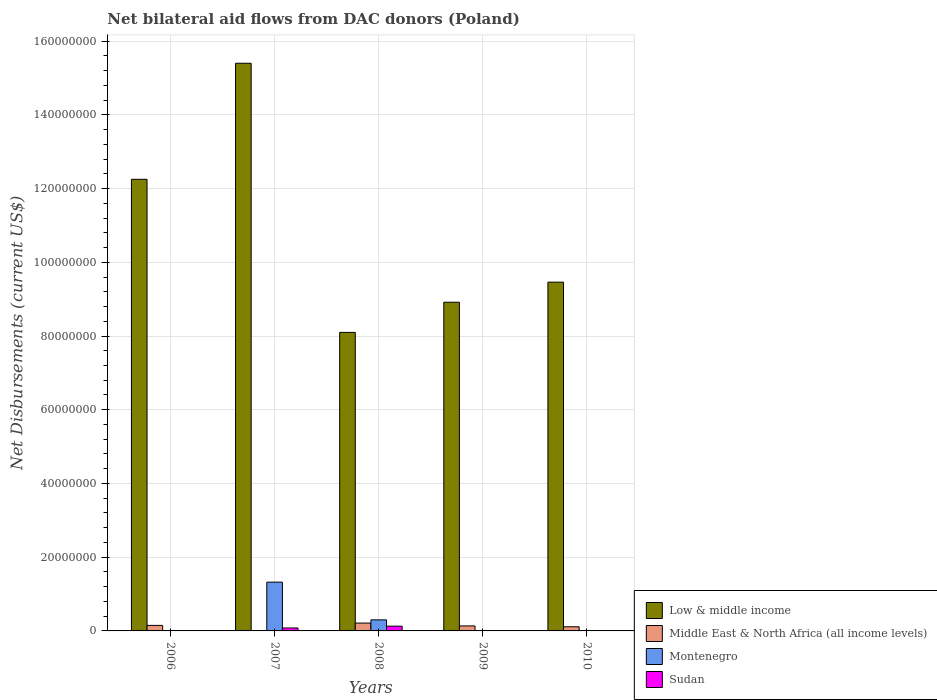Are the number of bars on each tick of the X-axis equal?
Your answer should be compact. No. How many bars are there on the 5th tick from the left?
Your answer should be compact. 3. How many bars are there on the 3rd tick from the right?
Your answer should be very brief. 4. What is the net bilateral aid flows in Low & middle income in 2008?
Offer a terse response. 8.10e+07. Across all years, what is the maximum net bilateral aid flows in Low & middle income?
Offer a terse response. 1.54e+08. Across all years, what is the minimum net bilateral aid flows in Low & middle income?
Make the answer very short. 8.10e+07. In which year was the net bilateral aid flows in Middle East & North Africa (all income levels) maximum?
Your response must be concise. 2008. What is the total net bilateral aid flows in Sudan in the graph?
Offer a terse response. 2.22e+06. What is the difference between the net bilateral aid flows in Sudan in 2007 and that in 2009?
Keep it short and to the point. 7.90e+05. What is the difference between the net bilateral aid flows in Low & middle income in 2009 and the net bilateral aid flows in Montenegro in 2006?
Offer a terse response. 8.91e+07. What is the average net bilateral aid flows in Middle East & North Africa (all income levels) per year?
Your answer should be compact. 1.22e+06. In the year 2010, what is the difference between the net bilateral aid flows in Sudan and net bilateral aid flows in Low & middle income?
Your response must be concise. -9.46e+07. What is the ratio of the net bilateral aid flows in Montenegro in 2006 to that in 2009?
Your answer should be compact. 2.25. Is the difference between the net bilateral aid flows in Sudan in 2007 and 2008 greater than the difference between the net bilateral aid flows in Low & middle income in 2007 and 2008?
Your answer should be compact. No. What is the difference between the highest and the lowest net bilateral aid flows in Sudan?
Your answer should be very brief. 1.28e+06. In how many years, is the net bilateral aid flows in Sudan greater than the average net bilateral aid flows in Sudan taken over all years?
Offer a terse response. 2. Is the sum of the net bilateral aid flows in Low & middle income in 2008 and 2009 greater than the maximum net bilateral aid flows in Middle East & North Africa (all income levels) across all years?
Keep it short and to the point. Yes. How many bars are there?
Offer a very short reply. 18. Are all the bars in the graph horizontal?
Provide a succinct answer. No. How many years are there in the graph?
Your response must be concise. 5. Are the values on the major ticks of Y-axis written in scientific E-notation?
Provide a short and direct response. No. Does the graph contain grids?
Offer a very short reply. Yes. Where does the legend appear in the graph?
Your answer should be compact. Bottom right. How many legend labels are there?
Your response must be concise. 4. What is the title of the graph?
Make the answer very short. Net bilateral aid flows from DAC donors (Poland). What is the label or title of the X-axis?
Give a very brief answer. Years. What is the label or title of the Y-axis?
Make the answer very short. Net Disbursements (current US$). What is the Net Disbursements (current US$) in Low & middle income in 2006?
Your answer should be very brief. 1.23e+08. What is the Net Disbursements (current US$) of Middle East & North Africa (all income levels) in 2006?
Provide a succinct answer. 1.50e+06. What is the Net Disbursements (current US$) in Low & middle income in 2007?
Keep it short and to the point. 1.54e+08. What is the Net Disbursements (current US$) in Montenegro in 2007?
Your response must be concise. 1.32e+07. What is the Net Disbursements (current US$) of Sudan in 2007?
Your answer should be compact. 8.00e+05. What is the Net Disbursements (current US$) of Low & middle income in 2008?
Your answer should be very brief. 8.10e+07. What is the Net Disbursements (current US$) of Middle East & North Africa (all income levels) in 2008?
Keep it short and to the point. 2.13e+06. What is the Net Disbursements (current US$) in Sudan in 2008?
Your answer should be compact. 1.29e+06. What is the Net Disbursements (current US$) in Low & middle income in 2009?
Provide a short and direct response. 8.92e+07. What is the Net Disbursements (current US$) of Middle East & North Africa (all income levels) in 2009?
Your answer should be compact. 1.36e+06. What is the Net Disbursements (current US$) of Sudan in 2009?
Your answer should be very brief. 10000. What is the Net Disbursements (current US$) of Low & middle income in 2010?
Offer a terse response. 9.46e+07. What is the Net Disbursements (current US$) of Middle East & North Africa (all income levels) in 2010?
Provide a short and direct response. 1.13e+06. What is the Net Disbursements (current US$) of Montenegro in 2010?
Offer a very short reply. 0. What is the Net Disbursements (current US$) of Sudan in 2010?
Keep it short and to the point. 6.00e+04. Across all years, what is the maximum Net Disbursements (current US$) of Low & middle income?
Your answer should be very brief. 1.54e+08. Across all years, what is the maximum Net Disbursements (current US$) in Middle East & North Africa (all income levels)?
Make the answer very short. 2.13e+06. Across all years, what is the maximum Net Disbursements (current US$) of Montenegro?
Offer a very short reply. 1.32e+07. Across all years, what is the maximum Net Disbursements (current US$) in Sudan?
Keep it short and to the point. 1.29e+06. Across all years, what is the minimum Net Disbursements (current US$) in Low & middle income?
Offer a very short reply. 8.10e+07. What is the total Net Disbursements (current US$) of Low & middle income in the graph?
Your answer should be compact. 5.41e+08. What is the total Net Disbursements (current US$) in Middle East & North Africa (all income levels) in the graph?
Your answer should be compact. 6.12e+06. What is the total Net Disbursements (current US$) in Montenegro in the graph?
Provide a succinct answer. 1.64e+07. What is the total Net Disbursements (current US$) in Sudan in the graph?
Provide a succinct answer. 2.22e+06. What is the difference between the Net Disbursements (current US$) in Low & middle income in 2006 and that in 2007?
Your response must be concise. -3.15e+07. What is the difference between the Net Disbursements (current US$) of Montenegro in 2006 and that in 2007?
Your answer should be very brief. -1.31e+07. What is the difference between the Net Disbursements (current US$) in Sudan in 2006 and that in 2007?
Your response must be concise. -7.40e+05. What is the difference between the Net Disbursements (current US$) in Low & middle income in 2006 and that in 2008?
Provide a short and direct response. 4.15e+07. What is the difference between the Net Disbursements (current US$) of Middle East & North Africa (all income levels) in 2006 and that in 2008?
Your answer should be very brief. -6.30e+05. What is the difference between the Net Disbursements (current US$) of Montenegro in 2006 and that in 2008?
Provide a succinct answer. -2.91e+06. What is the difference between the Net Disbursements (current US$) in Sudan in 2006 and that in 2008?
Make the answer very short. -1.23e+06. What is the difference between the Net Disbursements (current US$) in Low & middle income in 2006 and that in 2009?
Ensure brevity in your answer.  3.34e+07. What is the difference between the Net Disbursements (current US$) in Montenegro in 2006 and that in 2009?
Offer a very short reply. 5.00e+04. What is the difference between the Net Disbursements (current US$) in Low & middle income in 2006 and that in 2010?
Give a very brief answer. 2.79e+07. What is the difference between the Net Disbursements (current US$) in Middle East & North Africa (all income levels) in 2006 and that in 2010?
Make the answer very short. 3.70e+05. What is the difference between the Net Disbursements (current US$) in Low & middle income in 2007 and that in 2008?
Offer a very short reply. 7.30e+07. What is the difference between the Net Disbursements (current US$) of Montenegro in 2007 and that in 2008?
Give a very brief answer. 1.02e+07. What is the difference between the Net Disbursements (current US$) in Sudan in 2007 and that in 2008?
Ensure brevity in your answer.  -4.90e+05. What is the difference between the Net Disbursements (current US$) of Low & middle income in 2007 and that in 2009?
Your answer should be compact. 6.48e+07. What is the difference between the Net Disbursements (current US$) of Montenegro in 2007 and that in 2009?
Keep it short and to the point. 1.32e+07. What is the difference between the Net Disbursements (current US$) of Sudan in 2007 and that in 2009?
Keep it short and to the point. 7.90e+05. What is the difference between the Net Disbursements (current US$) of Low & middle income in 2007 and that in 2010?
Ensure brevity in your answer.  5.94e+07. What is the difference between the Net Disbursements (current US$) in Sudan in 2007 and that in 2010?
Give a very brief answer. 7.40e+05. What is the difference between the Net Disbursements (current US$) in Low & middle income in 2008 and that in 2009?
Ensure brevity in your answer.  -8.18e+06. What is the difference between the Net Disbursements (current US$) of Middle East & North Africa (all income levels) in 2008 and that in 2009?
Offer a terse response. 7.70e+05. What is the difference between the Net Disbursements (current US$) of Montenegro in 2008 and that in 2009?
Provide a short and direct response. 2.96e+06. What is the difference between the Net Disbursements (current US$) of Sudan in 2008 and that in 2009?
Your answer should be compact. 1.28e+06. What is the difference between the Net Disbursements (current US$) in Low & middle income in 2008 and that in 2010?
Your answer should be compact. -1.36e+07. What is the difference between the Net Disbursements (current US$) in Sudan in 2008 and that in 2010?
Offer a very short reply. 1.23e+06. What is the difference between the Net Disbursements (current US$) of Low & middle income in 2009 and that in 2010?
Make the answer very short. -5.45e+06. What is the difference between the Net Disbursements (current US$) in Middle East & North Africa (all income levels) in 2009 and that in 2010?
Keep it short and to the point. 2.30e+05. What is the difference between the Net Disbursements (current US$) of Low & middle income in 2006 and the Net Disbursements (current US$) of Montenegro in 2007?
Your response must be concise. 1.09e+08. What is the difference between the Net Disbursements (current US$) of Low & middle income in 2006 and the Net Disbursements (current US$) of Sudan in 2007?
Provide a short and direct response. 1.22e+08. What is the difference between the Net Disbursements (current US$) in Middle East & North Africa (all income levels) in 2006 and the Net Disbursements (current US$) in Montenegro in 2007?
Make the answer very short. -1.17e+07. What is the difference between the Net Disbursements (current US$) in Montenegro in 2006 and the Net Disbursements (current US$) in Sudan in 2007?
Provide a succinct answer. -7.10e+05. What is the difference between the Net Disbursements (current US$) of Low & middle income in 2006 and the Net Disbursements (current US$) of Middle East & North Africa (all income levels) in 2008?
Keep it short and to the point. 1.20e+08. What is the difference between the Net Disbursements (current US$) of Low & middle income in 2006 and the Net Disbursements (current US$) of Montenegro in 2008?
Give a very brief answer. 1.20e+08. What is the difference between the Net Disbursements (current US$) of Low & middle income in 2006 and the Net Disbursements (current US$) of Sudan in 2008?
Provide a succinct answer. 1.21e+08. What is the difference between the Net Disbursements (current US$) in Middle East & North Africa (all income levels) in 2006 and the Net Disbursements (current US$) in Montenegro in 2008?
Your answer should be very brief. -1.50e+06. What is the difference between the Net Disbursements (current US$) in Montenegro in 2006 and the Net Disbursements (current US$) in Sudan in 2008?
Keep it short and to the point. -1.20e+06. What is the difference between the Net Disbursements (current US$) in Low & middle income in 2006 and the Net Disbursements (current US$) in Middle East & North Africa (all income levels) in 2009?
Offer a very short reply. 1.21e+08. What is the difference between the Net Disbursements (current US$) of Low & middle income in 2006 and the Net Disbursements (current US$) of Montenegro in 2009?
Make the answer very short. 1.22e+08. What is the difference between the Net Disbursements (current US$) in Low & middle income in 2006 and the Net Disbursements (current US$) in Sudan in 2009?
Give a very brief answer. 1.22e+08. What is the difference between the Net Disbursements (current US$) in Middle East & North Africa (all income levels) in 2006 and the Net Disbursements (current US$) in Montenegro in 2009?
Your answer should be compact. 1.46e+06. What is the difference between the Net Disbursements (current US$) in Middle East & North Africa (all income levels) in 2006 and the Net Disbursements (current US$) in Sudan in 2009?
Give a very brief answer. 1.49e+06. What is the difference between the Net Disbursements (current US$) in Low & middle income in 2006 and the Net Disbursements (current US$) in Middle East & North Africa (all income levels) in 2010?
Make the answer very short. 1.21e+08. What is the difference between the Net Disbursements (current US$) in Low & middle income in 2006 and the Net Disbursements (current US$) in Sudan in 2010?
Provide a short and direct response. 1.22e+08. What is the difference between the Net Disbursements (current US$) of Middle East & North Africa (all income levels) in 2006 and the Net Disbursements (current US$) of Sudan in 2010?
Your answer should be very brief. 1.44e+06. What is the difference between the Net Disbursements (current US$) of Low & middle income in 2007 and the Net Disbursements (current US$) of Middle East & North Africa (all income levels) in 2008?
Offer a very short reply. 1.52e+08. What is the difference between the Net Disbursements (current US$) of Low & middle income in 2007 and the Net Disbursements (current US$) of Montenegro in 2008?
Your answer should be very brief. 1.51e+08. What is the difference between the Net Disbursements (current US$) in Low & middle income in 2007 and the Net Disbursements (current US$) in Sudan in 2008?
Offer a very short reply. 1.53e+08. What is the difference between the Net Disbursements (current US$) in Montenegro in 2007 and the Net Disbursements (current US$) in Sudan in 2008?
Your response must be concise. 1.19e+07. What is the difference between the Net Disbursements (current US$) in Low & middle income in 2007 and the Net Disbursements (current US$) in Middle East & North Africa (all income levels) in 2009?
Provide a short and direct response. 1.53e+08. What is the difference between the Net Disbursements (current US$) of Low & middle income in 2007 and the Net Disbursements (current US$) of Montenegro in 2009?
Provide a succinct answer. 1.54e+08. What is the difference between the Net Disbursements (current US$) in Low & middle income in 2007 and the Net Disbursements (current US$) in Sudan in 2009?
Ensure brevity in your answer.  1.54e+08. What is the difference between the Net Disbursements (current US$) of Montenegro in 2007 and the Net Disbursements (current US$) of Sudan in 2009?
Ensure brevity in your answer.  1.32e+07. What is the difference between the Net Disbursements (current US$) in Low & middle income in 2007 and the Net Disbursements (current US$) in Middle East & North Africa (all income levels) in 2010?
Offer a terse response. 1.53e+08. What is the difference between the Net Disbursements (current US$) of Low & middle income in 2007 and the Net Disbursements (current US$) of Sudan in 2010?
Give a very brief answer. 1.54e+08. What is the difference between the Net Disbursements (current US$) in Montenegro in 2007 and the Net Disbursements (current US$) in Sudan in 2010?
Keep it short and to the point. 1.32e+07. What is the difference between the Net Disbursements (current US$) of Low & middle income in 2008 and the Net Disbursements (current US$) of Middle East & North Africa (all income levels) in 2009?
Ensure brevity in your answer.  7.96e+07. What is the difference between the Net Disbursements (current US$) in Low & middle income in 2008 and the Net Disbursements (current US$) in Montenegro in 2009?
Provide a succinct answer. 8.09e+07. What is the difference between the Net Disbursements (current US$) of Low & middle income in 2008 and the Net Disbursements (current US$) of Sudan in 2009?
Keep it short and to the point. 8.10e+07. What is the difference between the Net Disbursements (current US$) of Middle East & North Africa (all income levels) in 2008 and the Net Disbursements (current US$) of Montenegro in 2009?
Provide a succinct answer. 2.09e+06. What is the difference between the Net Disbursements (current US$) in Middle East & North Africa (all income levels) in 2008 and the Net Disbursements (current US$) in Sudan in 2009?
Offer a very short reply. 2.12e+06. What is the difference between the Net Disbursements (current US$) in Montenegro in 2008 and the Net Disbursements (current US$) in Sudan in 2009?
Keep it short and to the point. 2.99e+06. What is the difference between the Net Disbursements (current US$) in Low & middle income in 2008 and the Net Disbursements (current US$) in Middle East & North Africa (all income levels) in 2010?
Your answer should be compact. 7.98e+07. What is the difference between the Net Disbursements (current US$) of Low & middle income in 2008 and the Net Disbursements (current US$) of Sudan in 2010?
Offer a terse response. 8.09e+07. What is the difference between the Net Disbursements (current US$) of Middle East & North Africa (all income levels) in 2008 and the Net Disbursements (current US$) of Sudan in 2010?
Keep it short and to the point. 2.07e+06. What is the difference between the Net Disbursements (current US$) of Montenegro in 2008 and the Net Disbursements (current US$) of Sudan in 2010?
Your response must be concise. 2.94e+06. What is the difference between the Net Disbursements (current US$) of Low & middle income in 2009 and the Net Disbursements (current US$) of Middle East & North Africa (all income levels) in 2010?
Your answer should be very brief. 8.80e+07. What is the difference between the Net Disbursements (current US$) of Low & middle income in 2009 and the Net Disbursements (current US$) of Sudan in 2010?
Your response must be concise. 8.91e+07. What is the difference between the Net Disbursements (current US$) of Middle East & North Africa (all income levels) in 2009 and the Net Disbursements (current US$) of Sudan in 2010?
Your answer should be compact. 1.30e+06. What is the average Net Disbursements (current US$) in Low & middle income per year?
Offer a terse response. 1.08e+08. What is the average Net Disbursements (current US$) of Middle East & North Africa (all income levels) per year?
Give a very brief answer. 1.22e+06. What is the average Net Disbursements (current US$) of Montenegro per year?
Offer a terse response. 3.27e+06. What is the average Net Disbursements (current US$) in Sudan per year?
Your answer should be very brief. 4.44e+05. In the year 2006, what is the difference between the Net Disbursements (current US$) of Low & middle income and Net Disbursements (current US$) of Middle East & North Africa (all income levels)?
Offer a very short reply. 1.21e+08. In the year 2006, what is the difference between the Net Disbursements (current US$) of Low & middle income and Net Disbursements (current US$) of Montenegro?
Your response must be concise. 1.22e+08. In the year 2006, what is the difference between the Net Disbursements (current US$) in Low & middle income and Net Disbursements (current US$) in Sudan?
Give a very brief answer. 1.22e+08. In the year 2006, what is the difference between the Net Disbursements (current US$) in Middle East & North Africa (all income levels) and Net Disbursements (current US$) in Montenegro?
Ensure brevity in your answer.  1.41e+06. In the year 2006, what is the difference between the Net Disbursements (current US$) in Middle East & North Africa (all income levels) and Net Disbursements (current US$) in Sudan?
Give a very brief answer. 1.44e+06. In the year 2007, what is the difference between the Net Disbursements (current US$) of Low & middle income and Net Disbursements (current US$) of Montenegro?
Provide a succinct answer. 1.41e+08. In the year 2007, what is the difference between the Net Disbursements (current US$) of Low & middle income and Net Disbursements (current US$) of Sudan?
Your answer should be compact. 1.53e+08. In the year 2007, what is the difference between the Net Disbursements (current US$) of Montenegro and Net Disbursements (current US$) of Sudan?
Ensure brevity in your answer.  1.24e+07. In the year 2008, what is the difference between the Net Disbursements (current US$) in Low & middle income and Net Disbursements (current US$) in Middle East & North Africa (all income levels)?
Offer a very short reply. 7.88e+07. In the year 2008, what is the difference between the Net Disbursements (current US$) of Low & middle income and Net Disbursements (current US$) of Montenegro?
Provide a short and direct response. 7.80e+07. In the year 2008, what is the difference between the Net Disbursements (current US$) in Low & middle income and Net Disbursements (current US$) in Sudan?
Make the answer very short. 7.97e+07. In the year 2008, what is the difference between the Net Disbursements (current US$) of Middle East & North Africa (all income levels) and Net Disbursements (current US$) of Montenegro?
Give a very brief answer. -8.70e+05. In the year 2008, what is the difference between the Net Disbursements (current US$) in Middle East & North Africa (all income levels) and Net Disbursements (current US$) in Sudan?
Provide a succinct answer. 8.40e+05. In the year 2008, what is the difference between the Net Disbursements (current US$) of Montenegro and Net Disbursements (current US$) of Sudan?
Keep it short and to the point. 1.71e+06. In the year 2009, what is the difference between the Net Disbursements (current US$) of Low & middle income and Net Disbursements (current US$) of Middle East & North Africa (all income levels)?
Your answer should be very brief. 8.78e+07. In the year 2009, what is the difference between the Net Disbursements (current US$) in Low & middle income and Net Disbursements (current US$) in Montenegro?
Offer a very short reply. 8.91e+07. In the year 2009, what is the difference between the Net Disbursements (current US$) in Low & middle income and Net Disbursements (current US$) in Sudan?
Make the answer very short. 8.92e+07. In the year 2009, what is the difference between the Net Disbursements (current US$) of Middle East & North Africa (all income levels) and Net Disbursements (current US$) of Montenegro?
Your answer should be compact. 1.32e+06. In the year 2009, what is the difference between the Net Disbursements (current US$) in Middle East & North Africa (all income levels) and Net Disbursements (current US$) in Sudan?
Give a very brief answer. 1.35e+06. In the year 2010, what is the difference between the Net Disbursements (current US$) in Low & middle income and Net Disbursements (current US$) in Middle East & North Africa (all income levels)?
Give a very brief answer. 9.35e+07. In the year 2010, what is the difference between the Net Disbursements (current US$) of Low & middle income and Net Disbursements (current US$) of Sudan?
Keep it short and to the point. 9.46e+07. In the year 2010, what is the difference between the Net Disbursements (current US$) of Middle East & North Africa (all income levels) and Net Disbursements (current US$) of Sudan?
Make the answer very short. 1.07e+06. What is the ratio of the Net Disbursements (current US$) in Low & middle income in 2006 to that in 2007?
Ensure brevity in your answer.  0.8. What is the ratio of the Net Disbursements (current US$) of Montenegro in 2006 to that in 2007?
Keep it short and to the point. 0.01. What is the ratio of the Net Disbursements (current US$) of Sudan in 2006 to that in 2007?
Your answer should be very brief. 0.07. What is the ratio of the Net Disbursements (current US$) in Low & middle income in 2006 to that in 2008?
Make the answer very short. 1.51. What is the ratio of the Net Disbursements (current US$) in Middle East & North Africa (all income levels) in 2006 to that in 2008?
Provide a succinct answer. 0.7. What is the ratio of the Net Disbursements (current US$) of Sudan in 2006 to that in 2008?
Keep it short and to the point. 0.05. What is the ratio of the Net Disbursements (current US$) in Low & middle income in 2006 to that in 2009?
Your answer should be compact. 1.37. What is the ratio of the Net Disbursements (current US$) of Middle East & North Africa (all income levels) in 2006 to that in 2009?
Your response must be concise. 1.1. What is the ratio of the Net Disbursements (current US$) of Montenegro in 2006 to that in 2009?
Your answer should be compact. 2.25. What is the ratio of the Net Disbursements (current US$) in Sudan in 2006 to that in 2009?
Your response must be concise. 6. What is the ratio of the Net Disbursements (current US$) of Low & middle income in 2006 to that in 2010?
Your answer should be compact. 1.29. What is the ratio of the Net Disbursements (current US$) in Middle East & North Africa (all income levels) in 2006 to that in 2010?
Provide a short and direct response. 1.33. What is the ratio of the Net Disbursements (current US$) in Sudan in 2006 to that in 2010?
Your answer should be compact. 1. What is the ratio of the Net Disbursements (current US$) in Low & middle income in 2007 to that in 2008?
Offer a very short reply. 1.9. What is the ratio of the Net Disbursements (current US$) in Montenegro in 2007 to that in 2008?
Provide a short and direct response. 4.41. What is the ratio of the Net Disbursements (current US$) of Sudan in 2007 to that in 2008?
Your response must be concise. 0.62. What is the ratio of the Net Disbursements (current US$) in Low & middle income in 2007 to that in 2009?
Offer a very short reply. 1.73. What is the ratio of the Net Disbursements (current US$) of Montenegro in 2007 to that in 2009?
Keep it short and to the point. 330.75. What is the ratio of the Net Disbursements (current US$) in Low & middle income in 2007 to that in 2010?
Keep it short and to the point. 1.63. What is the ratio of the Net Disbursements (current US$) of Sudan in 2007 to that in 2010?
Keep it short and to the point. 13.33. What is the ratio of the Net Disbursements (current US$) of Low & middle income in 2008 to that in 2009?
Your answer should be compact. 0.91. What is the ratio of the Net Disbursements (current US$) in Middle East & North Africa (all income levels) in 2008 to that in 2009?
Offer a very short reply. 1.57. What is the ratio of the Net Disbursements (current US$) of Montenegro in 2008 to that in 2009?
Keep it short and to the point. 75. What is the ratio of the Net Disbursements (current US$) of Sudan in 2008 to that in 2009?
Make the answer very short. 129. What is the ratio of the Net Disbursements (current US$) of Low & middle income in 2008 to that in 2010?
Your response must be concise. 0.86. What is the ratio of the Net Disbursements (current US$) in Middle East & North Africa (all income levels) in 2008 to that in 2010?
Give a very brief answer. 1.89. What is the ratio of the Net Disbursements (current US$) of Low & middle income in 2009 to that in 2010?
Keep it short and to the point. 0.94. What is the ratio of the Net Disbursements (current US$) in Middle East & North Africa (all income levels) in 2009 to that in 2010?
Ensure brevity in your answer.  1.2. What is the difference between the highest and the second highest Net Disbursements (current US$) in Low & middle income?
Provide a succinct answer. 3.15e+07. What is the difference between the highest and the second highest Net Disbursements (current US$) in Middle East & North Africa (all income levels)?
Offer a very short reply. 6.30e+05. What is the difference between the highest and the second highest Net Disbursements (current US$) in Montenegro?
Provide a succinct answer. 1.02e+07. What is the difference between the highest and the lowest Net Disbursements (current US$) of Low & middle income?
Keep it short and to the point. 7.30e+07. What is the difference between the highest and the lowest Net Disbursements (current US$) of Middle East & North Africa (all income levels)?
Give a very brief answer. 2.13e+06. What is the difference between the highest and the lowest Net Disbursements (current US$) of Montenegro?
Your answer should be very brief. 1.32e+07. What is the difference between the highest and the lowest Net Disbursements (current US$) of Sudan?
Offer a terse response. 1.28e+06. 